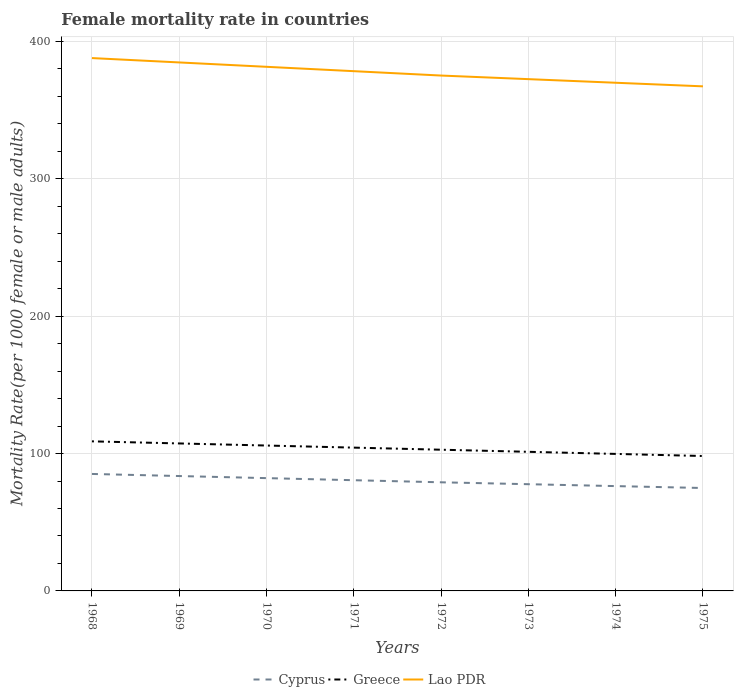How many different coloured lines are there?
Your response must be concise. 3. Is the number of lines equal to the number of legend labels?
Provide a succinct answer. Yes. Across all years, what is the maximum female mortality rate in Greece?
Give a very brief answer. 98.22. In which year was the female mortality rate in Cyprus maximum?
Offer a very short reply. 1975. What is the total female mortality rate in Lao PDR in the graph?
Your answer should be very brief. 9.54. What is the difference between the highest and the second highest female mortality rate in Cyprus?
Offer a terse response. 10.23. What is the difference between the highest and the lowest female mortality rate in Cyprus?
Your answer should be very brief. 4. How many lines are there?
Offer a very short reply. 3. How many years are there in the graph?
Give a very brief answer. 8. Does the graph contain grids?
Your answer should be compact. Yes. Where does the legend appear in the graph?
Keep it short and to the point. Bottom center. How many legend labels are there?
Make the answer very short. 3. How are the legend labels stacked?
Your answer should be very brief. Horizontal. What is the title of the graph?
Your answer should be compact. Female mortality rate in countries. What is the label or title of the X-axis?
Make the answer very short. Years. What is the label or title of the Y-axis?
Provide a short and direct response. Mortality Rate(per 1000 female or male adults). What is the Mortality Rate(per 1000 female or male adults) of Cyprus in 1968?
Your answer should be very brief. 85.16. What is the Mortality Rate(per 1000 female or male adults) in Greece in 1968?
Make the answer very short. 108.89. What is the Mortality Rate(per 1000 female or male adults) of Lao PDR in 1968?
Offer a terse response. 387.93. What is the Mortality Rate(per 1000 female or male adults) of Cyprus in 1969?
Offer a very short reply. 83.64. What is the Mortality Rate(per 1000 female or male adults) of Greece in 1969?
Your answer should be compact. 107.37. What is the Mortality Rate(per 1000 female or male adults) in Lao PDR in 1969?
Provide a succinct answer. 384.75. What is the Mortality Rate(per 1000 female or male adults) in Cyprus in 1970?
Offer a terse response. 82.12. What is the Mortality Rate(per 1000 female or male adults) of Greece in 1970?
Offer a terse response. 105.85. What is the Mortality Rate(per 1000 female or male adults) of Lao PDR in 1970?
Your answer should be very brief. 381.57. What is the Mortality Rate(per 1000 female or male adults) of Cyprus in 1971?
Provide a short and direct response. 80.6. What is the Mortality Rate(per 1000 female or male adults) in Greece in 1971?
Your answer should be compact. 104.33. What is the Mortality Rate(per 1000 female or male adults) of Lao PDR in 1971?
Your response must be concise. 378.39. What is the Mortality Rate(per 1000 female or male adults) in Cyprus in 1972?
Offer a terse response. 79.08. What is the Mortality Rate(per 1000 female or male adults) of Greece in 1972?
Your answer should be very brief. 102.8. What is the Mortality Rate(per 1000 female or male adults) of Lao PDR in 1972?
Provide a short and direct response. 375.2. What is the Mortality Rate(per 1000 female or male adults) in Cyprus in 1973?
Make the answer very short. 77.7. What is the Mortality Rate(per 1000 female or male adults) in Greece in 1973?
Keep it short and to the point. 101.28. What is the Mortality Rate(per 1000 female or male adults) of Lao PDR in 1973?
Give a very brief answer. 372.58. What is the Mortality Rate(per 1000 female or male adults) in Cyprus in 1974?
Give a very brief answer. 76.31. What is the Mortality Rate(per 1000 female or male adults) in Greece in 1974?
Keep it short and to the point. 99.75. What is the Mortality Rate(per 1000 female or male adults) in Lao PDR in 1974?
Ensure brevity in your answer.  369.96. What is the Mortality Rate(per 1000 female or male adults) of Cyprus in 1975?
Provide a succinct answer. 74.93. What is the Mortality Rate(per 1000 female or male adults) in Greece in 1975?
Your answer should be compact. 98.22. What is the Mortality Rate(per 1000 female or male adults) in Lao PDR in 1975?
Provide a short and direct response. 367.34. Across all years, what is the maximum Mortality Rate(per 1000 female or male adults) in Cyprus?
Offer a very short reply. 85.16. Across all years, what is the maximum Mortality Rate(per 1000 female or male adults) of Greece?
Keep it short and to the point. 108.89. Across all years, what is the maximum Mortality Rate(per 1000 female or male adults) in Lao PDR?
Offer a terse response. 387.93. Across all years, what is the minimum Mortality Rate(per 1000 female or male adults) in Cyprus?
Your answer should be very brief. 74.93. Across all years, what is the minimum Mortality Rate(per 1000 female or male adults) of Greece?
Your answer should be very brief. 98.22. Across all years, what is the minimum Mortality Rate(per 1000 female or male adults) of Lao PDR?
Your answer should be very brief. 367.34. What is the total Mortality Rate(per 1000 female or male adults) in Cyprus in the graph?
Your response must be concise. 639.53. What is the total Mortality Rate(per 1000 female or male adults) in Greece in the graph?
Your answer should be compact. 828.48. What is the total Mortality Rate(per 1000 female or male adults) of Lao PDR in the graph?
Your answer should be very brief. 3017.72. What is the difference between the Mortality Rate(per 1000 female or male adults) of Cyprus in 1968 and that in 1969?
Your answer should be compact. 1.52. What is the difference between the Mortality Rate(per 1000 female or male adults) of Greece in 1968 and that in 1969?
Give a very brief answer. 1.52. What is the difference between the Mortality Rate(per 1000 female or male adults) in Lao PDR in 1968 and that in 1969?
Offer a terse response. 3.18. What is the difference between the Mortality Rate(per 1000 female or male adults) of Cyprus in 1968 and that in 1970?
Keep it short and to the point. 3.04. What is the difference between the Mortality Rate(per 1000 female or male adults) of Greece in 1968 and that in 1970?
Provide a short and direct response. 3.04. What is the difference between the Mortality Rate(per 1000 female or male adults) of Lao PDR in 1968 and that in 1970?
Offer a very short reply. 6.36. What is the difference between the Mortality Rate(per 1000 female or male adults) of Cyprus in 1968 and that in 1971?
Make the answer very short. 4.56. What is the difference between the Mortality Rate(per 1000 female or male adults) of Greece in 1968 and that in 1971?
Give a very brief answer. 4.57. What is the difference between the Mortality Rate(per 1000 female or male adults) in Lao PDR in 1968 and that in 1971?
Provide a short and direct response. 9.54. What is the difference between the Mortality Rate(per 1000 female or male adults) of Cyprus in 1968 and that in 1972?
Give a very brief answer. 6.08. What is the difference between the Mortality Rate(per 1000 female or male adults) of Greece in 1968 and that in 1972?
Your answer should be very brief. 6.09. What is the difference between the Mortality Rate(per 1000 female or male adults) of Lao PDR in 1968 and that in 1972?
Your response must be concise. 12.72. What is the difference between the Mortality Rate(per 1000 female or male adults) of Cyprus in 1968 and that in 1973?
Give a very brief answer. 7.46. What is the difference between the Mortality Rate(per 1000 female or male adults) in Greece in 1968 and that in 1973?
Make the answer very short. 7.62. What is the difference between the Mortality Rate(per 1000 female or male adults) of Lao PDR in 1968 and that in 1973?
Make the answer very short. 15.34. What is the difference between the Mortality Rate(per 1000 female or male adults) of Cyprus in 1968 and that in 1974?
Offer a very short reply. 8.85. What is the difference between the Mortality Rate(per 1000 female or male adults) of Greece in 1968 and that in 1974?
Make the answer very short. 9.14. What is the difference between the Mortality Rate(per 1000 female or male adults) in Lao PDR in 1968 and that in 1974?
Your response must be concise. 17.96. What is the difference between the Mortality Rate(per 1000 female or male adults) in Cyprus in 1968 and that in 1975?
Your response must be concise. 10.23. What is the difference between the Mortality Rate(per 1000 female or male adults) of Greece in 1968 and that in 1975?
Ensure brevity in your answer.  10.67. What is the difference between the Mortality Rate(per 1000 female or male adults) in Lao PDR in 1968 and that in 1975?
Provide a short and direct response. 20.58. What is the difference between the Mortality Rate(per 1000 female or male adults) in Cyprus in 1969 and that in 1970?
Give a very brief answer. 1.52. What is the difference between the Mortality Rate(per 1000 female or male adults) of Greece in 1969 and that in 1970?
Your answer should be compact. 1.52. What is the difference between the Mortality Rate(per 1000 female or male adults) in Lao PDR in 1969 and that in 1970?
Provide a short and direct response. 3.18. What is the difference between the Mortality Rate(per 1000 female or male adults) in Cyprus in 1969 and that in 1971?
Offer a terse response. 3.04. What is the difference between the Mortality Rate(per 1000 female or male adults) of Greece in 1969 and that in 1971?
Ensure brevity in your answer.  3.04. What is the difference between the Mortality Rate(per 1000 female or male adults) in Lao PDR in 1969 and that in 1971?
Give a very brief answer. 6.36. What is the difference between the Mortality Rate(per 1000 female or male adults) of Cyprus in 1969 and that in 1972?
Offer a very short reply. 4.56. What is the difference between the Mortality Rate(per 1000 female or male adults) of Greece in 1969 and that in 1972?
Offer a terse response. 4.57. What is the difference between the Mortality Rate(per 1000 female or male adults) of Lao PDR in 1969 and that in 1972?
Your answer should be very brief. 9.54. What is the difference between the Mortality Rate(per 1000 female or male adults) in Cyprus in 1969 and that in 1973?
Your answer should be compact. 5.94. What is the difference between the Mortality Rate(per 1000 female or male adults) in Greece in 1969 and that in 1973?
Provide a succinct answer. 6.09. What is the difference between the Mortality Rate(per 1000 female or male adults) of Lao PDR in 1969 and that in 1973?
Keep it short and to the point. 12.16. What is the difference between the Mortality Rate(per 1000 female or male adults) in Cyprus in 1969 and that in 1974?
Your response must be concise. 7.33. What is the difference between the Mortality Rate(per 1000 female or male adults) in Greece in 1969 and that in 1974?
Offer a very short reply. 7.62. What is the difference between the Mortality Rate(per 1000 female or male adults) of Lao PDR in 1969 and that in 1974?
Provide a short and direct response. 14.78. What is the difference between the Mortality Rate(per 1000 female or male adults) of Cyprus in 1969 and that in 1975?
Provide a short and direct response. 8.71. What is the difference between the Mortality Rate(per 1000 female or male adults) in Greece in 1969 and that in 1975?
Offer a very short reply. 9.15. What is the difference between the Mortality Rate(per 1000 female or male adults) of Lao PDR in 1969 and that in 1975?
Offer a very short reply. 17.4. What is the difference between the Mortality Rate(per 1000 female or male adults) in Cyprus in 1970 and that in 1971?
Your answer should be very brief. 1.52. What is the difference between the Mortality Rate(per 1000 female or male adults) of Greece in 1970 and that in 1971?
Make the answer very short. 1.52. What is the difference between the Mortality Rate(per 1000 female or male adults) in Lao PDR in 1970 and that in 1971?
Keep it short and to the point. 3.18. What is the difference between the Mortality Rate(per 1000 female or male adults) of Cyprus in 1970 and that in 1972?
Your answer should be very brief. 3.04. What is the difference between the Mortality Rate(per 1000 female or male adults) of Greece in 1970 and that in 1972?
Give a very brief answer. 3.04. What is the difference between the Mortality Rate(per 1000 female or male adults) of Lao PDR in 1970 and that in 1972?
Give a very brief answer. 6.36. What is the difference between the Mortality Rate(per 1000 female or male adults) in Cyprus in 1970 and that in 1973?
Provide a succinct answer. 4.42. What is the difference between the Mortality Rate(per 1000 female or male adults) of Greece in 1970 and that in 1973?
Offer a very short reply. 4.57. What is the difference between the Mortality Rate(per 1000 female or male adults) in Lao PDR in 1970 and that in 1973?
Ensure brevity in your answer.  8.98. What is the difference between the Mortality Rate(per 1000 female or male adults) in Cyprus in 1970 and that in 1974?
Provide a succinct answer. 5.81. What is the difference between the Mortality Rate(per 1000 female or male adults) in Greece in 1970 and that in 1974?
Keep it short and to the point. 6.1. What is the difference between the Mortality Rate(per 1000 female or male adults) in Lao PDR in 1970 and that in 1974?
Give a very brief answer. 11.6. What is the difference between the Mortality Rate(per 1000 female or male adults) in Cyprus in 1970 and that in 1975?
Provide a short and direct response. 7.19. What is the difference between the Mortality Rate(per 1000 female or male adults) in Greece in 1970 and that in 1975?
Give a very brief answer. 7.63. What is the difference between the Mortality Rate(per 1000 female or male adults) of Lao PDR in 1970 and that in 1975?
Ensure brevity in your answer.  14.22. What is the difference between the Mortality Rate(per 1000 female or male adults) of Cyprus in 1971 and that in 1972?
Ensure brevity in your answer.  1.52. What is the difference between the Mortality Rate(per 1000 female or male adults) of Greece in 1971 and that in 1972?
Offer a terse response. 1.52. What is the difference between the Mortality Rate(per 1000 female or male adults) of Lao PDR in 1971 and that in 1972?
Give a very brief answer. 3.18. What is the difference between the Mortality Rate(per 1000 female or male adults) in Cyprus in 1971 and that in 1973?
Your response must be concise. 2.9. What is the difference between the Mortality Rate(per 1000 female or male adults) in Greece in 1971 and that in 1973?
Your answer should be very brief. 3.05. What is the difference between the Mortality Rate(per 1000 female or male adults) of Lao PDR in 1971 and that in 1973?
Keep it short and to the point. 5.8. What is the difference between the Mortality Rate(per 1000 female or male adults) of Cyprus in 1971 and that in 1974?
Your answer should be very brief. 4.29. What is the difference between the Mortality Rate(per 1000 female or male adults) of Greece in 1971 and that in 1974?
Ensure brevity in your answer.  4.58. What is the difference between the Mortality Rate(per 1000 female or male adults) in Lao PDR in 1971 and that in 1974?
Provide a succinct answer. 8.42. What is the difference between the Mortality Rate(per 1000 female or male adults) in Cyprus in 1971 and that in 1975?
Your response must be concise. 5.67. What is the difference between the Mortality Rate(per 1000 female or male adults) in Greece in 1971 and that in 1975?
Provide a short and direct response. 6.1. What is the difference between the Mortality Rate(per 1000 female or male adults) in Lao PDR in 1971 and that in 1975?
Make the answer very short. 11.04. What is the difference between the Mortality Rate(per 1000 female or male adults) in Cyprus in 1972 and that in 1973?
Your answer should be compact. 1.39. What is the difference between the Mortality Rate(per 1000 female or male adults) in Greece in 1972 and that in 1973?
Your answer should be very brief. 1.53. What is the difference between the Mortality Rate(per 1000 female or male adults) of Lao PDR in 1972 and that in 1973?
Provide a short and direct response. 2.62. What is the difference between the Mortality Rate(per 1000 female or male adults) in Cyprus in 1972 and that in 1974?
Provide a succinct answer. 2.77. What is the difference between the Mortality Rate(per 1000 female or male adults) of Greece in 1972 and that in 1974?
Offer a terse response. 3.05. What is the difference between the Mortality Rate(per 1000 female or male adults) of Lao PDR in 1972 and that in 1974?
Provide a short and direct response. 5.24. What is the difference between the Mortality Rate(per 1000 female or male adults) of Cyprus in 1972 and that in 1975?
Your answer should be compact. 4.16. What is the difference between the Mortality Rate(per 1000 female or male adults) in Greece in 1972 and that in 1975?
Offer a very short reply. 4.58. What is the difference between the Mortality Rate(per 1000 female or male adults) of Lao PDR in 1972 and that in 1975?
Your answer should be compact. 7.86. What is the difference between the Mortality Rate(per 1000 female or male adults) of Cyprus in 1973 and that in 1974?
Your answer should be very brief. 1.39. What is the difference between the Mortality Rate(per 1000 female or male adults) of Greece in 1973 and that in 1974?
Offer a terse response. 1.53. What is the difference between the Mortality Rate(per 1000 female or male adults) in Lao PDR in 1973 and that in 1974?
Provide a short and direct response. 2.62. What is the difference between the Mortality Rate(per 1000 female or male adults) of Cyprus in 1973 and that in 1975?
Provide a short and direct response. 2.77. What is the difference between the Mortality Rate(per 1000 female or male adults) in Greece in 1973 and that in 1975?
Make the answer very short. 3.05. What is the difference between the Mortality Rate(per 1000 female or male adults) in Lao PDR in 1973 and that in 1975?
Make the answer very short. 5.24. What is the difference between the Mortality Rate(per 1000 female or male adults) of Cyprus in 1974 and that in 1975?
Offer a very short reply. 1.39. What is the difference between the Mortality Rate(per 1000 female or male adults) of Greece in 1974 and that in 1975?
Give a very brief answer. 1.53. What is the difference between the Mortality Rate(per 1000 female or male adults) in Lao PDR in 1974 and that in 1975?
Provide a succinct answer. 2.62. What is the difference between the Mortality Rate(per 1000 female or male adults) in Cyprus in 1968 and the Mortality Rate(per 1000 female or male adults) in Greece in 1969?
Your answer should be compact. -22.21. What is the difference between the Mortality Rate(per 1000 female or male adults) of Cyprus in 1968 and the Mortality Rate(per 1000 female or male adults) of Lao PDR in 1969?
Your response must be concise. -299.59. What is the difference between the Mortality Rate(per 1000 female or male adults) of Greece in 1968 and the Mortality Rate(per 1000 female or male adults) of Lao PDR in 1969?
Your answer should be compact. -275.85. What is the difference between the Mortality Rate(per 1000 female or male adults) of Cyprus in 1968 and the Mortality Rate(per 1000 female or male adults) of Greece in 1970?
Offer a very short reply. -20.69. What is the difference between the Mortality Rate(per 1000 female or male adults) in Cyprus in 1968 and the Mortality Rate(per 1000 female or male adults) in Lao PDR in 1970?
Keep it short and to the point. -296.41. What is the difference between the Mortality Rate(per 1000 female or male adults) in Greece in 1968 and the Mortality Rate(per 1000 female or male adults) in Lao PDR in 1970?
Your response must be concise. -272.67. What is the difference between the Mortality Rate(per 1000 female or male adults) of Cyprus in 1968 and the Mortality Rate(per 1000 female or male adults) of Greece in 1971?
Ensure brevity in your answer.  -19.17. What is the difference between the Mortality Rate(per 1000 female or male adults) of Cyprus in 1968 and the Mortality Rate(per 1000 female or male adults) of Lao PDR in 1971?
Ensure brevity in your answer.  -293.23. What is the difference between the Mortality Rate(per 1000 female or male adults) of Greece in 1968 and the Mortality Rate(per 1000 female or male adults) of Lao PDR in 1971?
Offer a terse response. -269.49. What is the difference between the Mortality Rate(per 1000 female or male adults) in Cyprus in 1968 and the Mortality Rate(per 1000 female or male adults) in Greece in 1972?
Provide a succinct answer. -17.65. What is the difference between the Mortality Rate(per 1000 female or male adults) of Cyprus in 1968 and the Mortality Rate(per 1000 female or male adults) of Lao PDR in 1972?
Give a very brief answer. -290.05. What is the difference between the Mortality Rate(per 1000 female or male adults) in Greece in 1968 and the Mortality Rate(per 1000 female or male adults) in Lao PDR in 1972?
Give a very brief answer. -266.31. What is the difference between the Mortality Rate(per 1000 female or male adults) of Cyprus in 1968 and the Mortality Rate(per 1000 female or male adults) of Greece in 1973?
Offer a terse response. -16.12. What is the difference between the Mortality Rate(per 1000 female or male adults) of Cyprus in 1968 and the Mortality Rate(per 1000 female or male adults) of Lao PDR in 1973?
Your answer should be compact. -287.43. What is the difference between the Mortality Rate(per 1000 female or male adults) in Greece in 1968 and the Mortality Rate(per 1000 female or male adults) in Lao PDR in 1973?
Your answer should be compact. -263.69. What is the difference between the Mortality Rate(per 1000 female or male adults) in Cyprus in 1968 and the Mortality Rate(per 1000 female or male adults) in Greece in 1974?
Provide a short and direct response. -14.59. What is the difference between the Mortality Rate(per 1000 female or male adults) of Cyprus in 1968 and the Mortality Rate(per 1000 female or male adults) of Lao PDR in 1974?
Make the answer very short. -284.81. What is the difference between the Mortality Rate(per 1000 female or male adults) in Greece in 1968 and the Mortality Rate(per 1000 female or male adults) in Lao PDR in 1974?
Your answer should be very brief. -261.07. What is the difference between the Mortality Rate(per 1000 female or male adults) of Cyprus in 1968 and the Mortality Rate(per 1000 female or male adults) of Greece in 1975?
Provide a succinct answer. -13.06. What is the difference between the Mortality Rate(per 1000 female or male adults) of Cyprus in 1968 and the Mortality Rate(per 1000 female or male adults) of Lao PDR in 1975?
Provide a short and direct response. -282.19. What is the difference between the Mortality Rate(per 1000 female or male adults) of Greece in 1968 and the Mortality Rate(per 1000 female or male adults) of Lao PDR in 1975?
Offer a very short reply. -258.45. What is the difference between the Mortality Rate(per 1000 female or male adults) of Cyprus in 1969 and the Mortality Rate(per 1000 female or male adults) of Greece in 1970?
Your answer should be very brief. -22.21. What is the difference between the Mortality Rate(per 1000 female or male adults) in Cyprus in 1969 and the Mortality Rate(per 1000 female or male adults) in Lao PDR in 1970?
Offer a terse response. -297.93. What is the difference between the Mortality Rate(per 1000 female or male adults) of Greece in 1969 and the Mortality Rate(per 1000 female or male adults) of Lao PDR in 1970?
Your response must be concise. -274.2. What is the difference between the Mortality Rate(per 1000 female or male adults) in Cyprus in 1969 and the Mortality Rate(per 1000 female or male adults) in Greece in 1971?
Make the answer very short. -20.69. What is the difference between the Mortality Rate(per 1000 female or male adults) of Cyprus in 1969 and the Mortality Rate(per 1000 female or male adults) of Lao PDR in 1971?
Your answer should be very brief. -294.75. What is the difference between the Mortality Rate(per 1000 female or male adults) in Greece in 1969 and the Mortality Rate(per 1000 female or male adults) in Lao PDR in 1971?
Offer a terse response. -271.02. What is the difference between the Mortality Rate(per 1000 female or male adults) in Cyprus in 1969 and the Mortality Rate(per 1000 female or male adults) in Greece in 1972?
Your answer should be very brief. -19.16. What is the difference between the Mortality Rate(per 1000 female or male adults) of Cyprus in 1969 and the Mortality Rate(per 1000 female or male adults) of Lao PDR in 1972?
Your response must be concise. -291.57. What is the difference between the Mortality Rate(per 1000 female or male adults) of Greece in 1969 and the Mortality Rate(per 1000 female or male adults) of Lao PDR in 1972?
Your response must be concise. -267.83. What is the difference between the Mortality Rate(per 1000 female or male adults) in Cyprus in 1969 and the Mortality Rate(per 1000 female or male adults) in Greece in 1973?
Your answer should be compact. -17.64. What is the difference between the Mortality Rate(per 1000 female or male adults) in Cyprus in 1969 and the Mortality Rate(per 1000 female or male adults) in Lao PDR in 1973?
Keep it short and to the point. -288.95. What is the difference between the Mortality Rate(per 1000 female or male adults) in Greece in 1969 and the Mortality Rate(per 1000 female or male adults) in Lao PDR in 1973?
Ensure brevity in your answer.  -265.21. What is the difference between the Mortality Rate(per 1000 female or male adults) in Cyprus in 1969 and the Mortality Rate(per 1000 female or male adults) in Greece in 1974?
Provide a succinct answer. -16.11. What is the difference between the Mortality Rate(per 1000 female or male adults) of Cyprus in 1969 and the Mortality Rate(per 1000 female or male adults) of Lao PDR in 1974?
Your answer should be compact. -286.32. What is the difference between the Mortality Rate(per 1000 female or male adults) of Greece in 1969 and the Mortality Rate(per 1000 female or male adults) of Lao PDR in 1974?
Ensure brevity in your answer.  -262.59. What is the difference between the Mortality Rate(per 1000 female or male adults) of Cyprus in 1969 and the Mortality Rate(per 1000 female or male adults) of Greece in 1975?
Your answer should be compact. -14.58. What is the difference between the Mortality Rate(per 1000 female or male adults) of Cyprus in 1969 and the Mortality Rate(per 1000 female or male adults) of Lao PDR in 1975?
Provide a short and direct response. -283.7. What is the difference between the Mortality Rate(per 1000 female or male adults) of Greece in 1969 and the Mortality Rate(per 1000 female or male adults) of Lao PDR in 1975?
Ensure brevity in your answer.  -259.97. What is the difference between the Mortality Rate(per 1000 female or male adults) of Cyprus in 1970 and the Mortality Rate(per 1000 female or male adults) of Greece in 1971?
Give a very brief answer. -22.21. What is the difference between the Mortality Rate(per 1000 female or male adults) in Cyprus in 1970 and the Mortality Rate(per 1000 female or male adults) in Lao PDR in 1971?
Make the answer very short. -296.27. What is the difference between the Mortality Rate(per 1000 female or male adults) in Greece in 1970 and the Mortality Rate(per 1000 female or male adults) in Lao PDR in 1971?
Ensure brevity in your answer.  -272.54. What is the difference between the Mortality Rate(per 1000 female or male adults) of Cyprus in 1970 and the Mortality Rate(per 1000 female or male adults) of Greece in 1972?
Keep it short and to the point. -20.68. What is the difference between the Mortality Rate(per 1000 female or male adults) in Cyprus in 1970 and the Mortality Rate(per 1000 female or male adults) in Lao PDR in 1972?
Give a very brief answer. -293.08. What is the difference between the Mortality Rate(per 1000 female or male adults) in Greece in 1970 and the Mortality Rate(per 1000 female or male adults) in Lao PDR in 1972?
Your answer should be compact. -269.36. What is the difference between the Mortality Rate(per 1000 female or male adults) in Cyprus in 1970 and the Mortality Rate(per 1000 female or male adults) in Greece in 1973?
Your response must be concise. -19.16. What is the difference between the Mortality Rate(per 1000 female or male adults) in Cyprus in 1970 and the Mortality Rate(per 1000 female or male adults) in Lao PDR in 1973?
Ensure brevity in your answer.  -290.46. What is the difference between the Mortality Rate(per 1000 female or male adults) in Greece in 1970 and the Mortality Rate(per 1000 female or male adults) in Lao PDR in 1973?
Offer a very short reply. -266.74. What is the difference between the Mortality Rate(per 1000 female or male adults) in Cyprus in 1970 and the Mortality Rate(per 1000 female or male adults) in Greece in 1974?
Your answer should be compact. -17.63. What is the difference between the Mortality Rate(per 1000 female or male adults) of Cyprus in 1970 and the Mortality Rate(per 1000 female or male adults) of Lao PDR in 1974?
Offer a terse response. -287.84. What is the difference between the Mortality Rate(per 1000 female or male adults) in Greece in 1970 and the Mortality Rate(per 1000 female or male adults) in Lao PDR in 1974?
Ensure brevity in your answer.  -264.12. What is the difference between the Mortality Rate(per 1000 female or male adults) in Cyprus in 1970 and the Mortality Rate(per 1000 female or male adults) in Greece in 1975?
Offer a terse response. -16.1. What is the difference between the Mortality Rate(per 1000 female or male adults) in Cyprus in 1970 and the Mortality Rate(per 1000 female or male adults) in Lao PDR in 1975?
Offer a very short reply. -285.22. What is the difference between the Mortality Rate(per 1000 female or male adults) in Greece in 1970 and the Mortality Rate(per 1000 female or male adults) in Lao PDR in 1975?
Give a very brief answer. -261.49. What is the difference between the Mortality Rate(per 1000 female or male adults) of Cyprus in 1971 and the Mortality Rate(per 1000 female or male adults) of Greece in 1972?
Provide a short and direct response. -22.2. What is the difference between the Mortality Rate(per 1000 female or male adults) of Cyprus in 1971 and the Mortality Rate(per 1000 female or male adults) of Lao PDR in 1972?
Give a very brief answer. -294.6. What is the difference between the Mortality Rate(per 1000 female or male adults) of Greece in 1971 and the Mortality Rate(per 1000 female or male adults) of Lao PDR in 1972?
Offer a terse response. -270.88. What is the difference between the Mortality Rate(per 1000 female or male adults) of Cyprus in 1971 and the Mortality Rate(per 1000 female or male adults) of Greece in 1973?
Make the answer very short. -20.67. What is the difference between the Mortality Rate(per 1000 female or male adults) in Cyprus in 1971 and the Mortality Rate(per 1000 female or male adults) in Lao PDR in 1973?
Offer a very short reply. -291.98. What is the difference between the Mortality Rate(per 1000 female or male adults) of Greece in 1971 and the Mortality Rate(per 1000 female or male adults) of Lao PDR in 1973?
Make the answer very short. -268.26. What is the difference between the Mortality Rate(per 1000 female or male adults) of Cyprus in 1971 and the Mortality Rate(per 1000 female or male adults) of Greece in 1974?
Provide a succinct answer. -19.15. What is the difference between the Mortality Rate(per 1000 female or male adults) of Cyprus in 1971 and the Mortality Rate(per 1000 female or male adults) of Lao PDR in 1974?
Keep it short and to the point. -289.36. What is the difference between the Mortality Rate(per 1000 female or male adults) of Greece in 1971 and the Mortality Rate(per 1000 female or male adults) of Lao PDR in 1974?
Your response must be concise. -265.64. What is the difference between the Mortality Rate(per 1000 female or male adults) in Cyprus in 1971 and the Mortality Rate(per 1000 female or male adults) in Greece in 1975?
Keep it short and to the point. -17.62. What is the difference between the Mortality Rate(per 1000 female or male adults) of Cyprus in 1971 and the Mortality Rate(per 1000 female or male adults) of Lao PDR in 1975?
Give a very brief answer. -286.74. What is the difference between the Mortality Rate(per 1000 female or male adults) of Greece in 1971 and the Mortality Rate(per 1000 female or male adults) of Lao PDR in 1975?
Offer a terse response. -263.02. What is the difference between the Mortality Rate(per 1000 female or male adults) in Cyprus in 1972 and the Mortality Rate(per 1000 female or male adults) in Greece in 1973?
Offer a terse response. -22.19. What is the difference between the Mortality Rate(per 1000 female or male adults) in Cyprus in 1972 and the Mortality Rate(per 1000 female or male adults) in Lao PDR in 1973?
Ensure brevity in your answer.  -293.5. What is the difference between the Mortality Rate(per 1000 female or male adults) in Greece in 1972 and the Mortality Rate(per 1000 female or male adults) in Lao PDR in 1973?
Your response must be concise. -269.78. What is the difference between the Mortality Rate(per 1000 female or male adults) of Cyprus in 1972 and the Mortality Rate(per 1000 female or male adults) of Greece in 1974?
Make the answer very short. -20.67. What is the difference between the Mortality Rate(per 1000 female or male adults) in Cyprus in 1972 and the Mortality Rate(per 1000 female or male adults) in Lao PDR in 1974?
Offer a terse response. -290.88. What is the difference between the Mortality Rate(per 1000 female or male adults) of Greece in 1972 and the Mortality Rate(per 1000 female or male adults) of Lao PDR in 1974?
Make the answer very short. -267.16. What is the difference between the Mortality Rate(per 1000 female or male adults) in Cyprus in 1972 and the Mortality Rate(per 1000 female or male adults) in Greece in 1975?
Ensure brevity in your answer.  -19.14. What is the difference between the Mortality Rate(per 1000 female or male adults) in Cyprus in 1972 and the Mortality Rate(per 1000 female or male adults) in Lao PDR in 1975?
Offer a very short reply. -288.26. What is the difference between the Mortality Rate(per 1000 female or male adults) in Greece in 1972 and the Mortality Rate(per 1000 female or male adults) in Lao PDR in 1975?
Your answer should be compact. -264.54. What is the difference between the Mortality Rate(per 1000 female or male adults) of Cyprus in 1973 and the Mortality Rate(per 1000 female or male adults) of Greece in 1974?
Provide a succinct answer. -22.05. What is the difference between the Mortality Rate(per 1000 female or male adults) of Cyprus in 1973 and the Mortality Rate(per 1000 female or male adults) of Lao PDR in 1974?
Keep it short and to the point. -292.27. What is the difference between the Mortality Rate(per 1000 female or male adults) in Greece in 1973 and the Mortality Rate(per 1000 female or male adults) in Lao PDR in 1974?
Your response must be concise. -268.69. What is the difference between the Mortality Rate(per 1000 female or male adults) of Cyprus in 1973 and the Mortality Rate(per 1000 female or male adults) of Greece in 1975?
Offer a terse response. -20.52. What is the difference between the Mortality Rate(per 1000 female or male adults) of Cyprus in 1973 and the Mortality Rate(per 1000 female or male adults) of Lao PDR in 1975?
Give a very brief answer. -289.64. What is the difference between the Mortality Rate(per 1000 female or male adults) of Greece in 1973 and the Mortality Rate(per 1000 female or male adults) of Lao PDR in 1975?
Make the answer very short. -266.07. What is the difference between the Mortality Rate(per 1000 female or male adults) of Cyprus in 1974 and the Mortality Rate(per 1000 female or male adults) of Greece in 1975?
Offer a very short reply. -21.91. What is the difference between the Mortality Rate(per 1000 female or male adults) of Cyprus in 1974 and the Mortality Rate(per 1000 female or male adults) of Lao PDR in 1975?
Your response must be concise. -291.03. What is the difference between the Mortality Rate(per 1000 female or male adults) of Greece in 1974 and the Mortality Rate(per 1000 female or male adults) of Lao PDR in 1975?
Make the answer very short. -267.59. What is the average Mortality Rate(per 1000 female or male adults) of Cyprus per year?
Offer a very short reply. 79.94. What is the average Mortality Rate(per 1000 female or male adults) of Greece per year?
Offer a very short reply. 103.56. What is the average Mortality Rate(per 1000 female or male adults) in Lao PDR per year?
Give a very brief answer. 377.21. In the year 1968, what is the difference between the Mortality Rate(per 1000 female or male adults) of Cyprus and Mortality Rate(per 1000 female or male adults) of Greece?
Ensure brevity in your answer.  -23.74. In the year 1968, what is the difference between the Mortality Rate(per 1000 female or male adults) of Cyprus and Mortality Rate(per 1000 female or male adults) of Lao PDR?
Your response must be concise. -302.77. In the year 1968, what is the difference between the Mortality Rate(per 1000 female or male adults) in Greece and Mortality Rate(per 1000 female or male adults) in Lao PDR?
Offer a terse response. -279.03. In the year 1969, what is the difference between the Mortality Rate(per 1000 female or male adults) in Cyprus and Mortality Rate(per 1000 female or male adults) in Greece?
Your answer should be compact. -23.73. In the year 1969, what is the difference between the Mortality Rate(per 1000 female or male adults) of Cyprus and Mortality Rate(per 1000 female or male adults) of Lao PDR?
Provide a short and direct response. -301.11. In the year 1969, what is the difference between the Mortality Rate(per 1000 female or male adults) in Greece and Mortality Rate(per 1000 female or male adults) in Lao PDR?
Provide a short and direct response. -277.38. In the year 1970, what is the difference between the Mortality Rate(per 1000 female or male adults) of Cyprus and Mortality Rate(per 1000 female or male adults) of Greece?
Your answer should be very brief. -23.73. In the year 1970, what is the difference between the Mortality Rate(per 1000 female or male adults) in Cyprus and Mortality Rate(per 1000 female or male adults) in Lao PDR?
Ensure brevity in your answer.  -299.45. In the year 1970, what is the difference between the Mortality Rate(per 1000 female or male adults) of Greece and Mortality Rate(per 1000 female or male adults) of Lao PDR?
Make the answer very short. -275.72. In the year 1971, what is the difference between the Mortality Rate(per 1000 female or male adults) in Cyprus and Mortality Rate(per 1000 female or male adults) in Greece?
Make the answer very short. -23.72. In the year 1971, what is the difference between the Mortality Rate(per 1000 female or male adults) of Cyprus and Mortality Rate(per 1000 female or male adults) of Lao PDR?
Provide a succinct answer. -297.79. In the year 1971, what is the difference between the Mortality Rate(per 1000 female or male adults) in Greece and Mortality Rate(per 1000 female or male adults) in Lao PDR?
Your response must be concise. -274.06. In the year 1972, what is the difference between the Mortality Rate(per 1000 female or male adults) of Cyprus and Mortality Rate(per 1000 female or male adults) of Greece?
Offer a terse response. -23.72. In the year 1972, what is the difference between the Mortality Rate(per 1000 female or male adults) in Cyprus and Mortality Rate(per 1000 female or male adults) in Lao PDR?
Provide a succinct answer. -296.12. In the year 1972, what is the difference between the Mortality Rate(per 1000 female or male adults) of Greece and Mortality Rate(per 1000 female or male adults) of Lao PDR?
Your answer should be very brief. -272.4. In the year 1973, what is the difference between the Mortality Rate(per 1000 female or male adults) in Cyprus and Mortality Rate(per 1000 female or male adults) in Greece?
Your response must be concise. -23.58. In the year 1973, what is the difference between the Mortality Rate(per 1000 female or male adults) in Cyprus and Mortality Rate(per 1000 female or male adults) in Lao PDR?
Your response must be concise. -294.89. In the year 1973, what is the difference between the Mortality Rate(per 1000 female or male adults) in Greece and Mortality Rate(per 1000 female or male adults) in Lao PDR?
Your response must be concise. -271.31. In the year 1974, what is the difference between the Mortality Rate(per 1000 female or male adults) of Cyprus and Mortality Rate(per 1000 female or male adults) of Greece?
Your response must be concise. -23.44. In the year 1974, what is the difference between the Mortality Rate(per 1000 female or male adults) in Cyprus and Mortality Rate(per 1000 female or male adults) in Lao PDR?
Offer a very short reply. -293.65. In the year 1974, what is the difference between the Mortality Rate(per 1000 female or male adults) of Greece and Mortality Rate(per 1000 female or male adults) of Lao PDR?
Your response must be concise. -270.21. In the year 1975, what is the difference between the Mortality Rate(per 1000 female or male adults) of Cyprus and Mortality Rate(per 1000 female or male adults) of Greece?
Your answer should be very brief. -23.3. In the year 1975, what is the difference between the Mortality Rate(per 1000 female or male adults) of Cyprus and Mortality Rate(per 1000 female or male adults) of Lao PDR?
Your answer should be very brief. -292.42. In the year 1975, what is the difference between the Mortality Rate(per 1000 female or male adults) of Greece and Mortality Rate(per 1000 female or male adults) of Lao PDR?
Your answer should be very brief. -269.12. What is the ratio of the Mortality Rate(per 1000 female or male adults) of Cyprus in 1968 to that in 1969?
Your answer should be compact. 1.02. What is the ratio of the Mortality Rate(per 1000 female or male adults) of Greece in 1968 to that in 1969?
Offer a very short reply. 1.01. What is the ratio of the Mortality Rate(per 1000 female or male adults) in Lao PDR in 1968 to that in 1969?
Provide a short and direct response. 1.01. What is the ratio of the Mortality Rate(per 1000 female or male adults) of Cyprus in 1968 to that in 1970?
Give a very brief answer. 1.04. What is the ratio of the Mortality Rate(per 1000 female or male adults) in Greece in 1968 to that in 1970?
Your answer should be very brief. 1.03. What is the ratio of the Mortality Rate(per 1000 female or male adults) of Lao PDR in 1968 to that in 1970?
Ensure brevity in your answer.  1.02. What is the ratio of the Mortality Rate(per 1000 female or male adults) of Cyprus in 1968 to that in 1971?
Your answer should be very brief. 1.06. What is the ratio of the Mortality Rate(per 1000 female or male adults) in Greece in 1968 to that in 1971?
Offer a very short reply. 1.04. What is the ratio of the Mortality Rate(per 1000 female or male adults) in Lao PDR in 1968 to that in 1971?
Provide a succinct answer. 1.03. What is the ratio of the Mortality Rate(per 1000 female or male adults) of Cyprus in 1968 to that in 1972?
Keep it short and to the point. 1.08. What is the ratio of the Mortality Rate(per 1000 female or male adults) in Greece in 1968 to that in 1972?
Ensure brevity in your answer.  1.06. What is the ratio of the Mortality Rate(per 1000 female or male adults) in Lao PDR in 1968 to that in 1972?
Your answer should be compact. 1.03. What is the ratio of the Mortality Rate(per 1000 female or male adults) in Cyprus in 1968 to that in 1973?
Provide a short and direct response. 1.1. What is the ratio of the Mortality Rate(per 1000 female or male adults) of Greece in 1968 to that in 1973?
Keep it short and to the point. 1.08. What is the ratio of the Mortality Rate(per 1000 female or male adults) in Lao PDR in 1968 to that in 1973?
Provide a short and direct response. 1.04. What is the ratio of the Mortality Rate(per 1000 female or male adults) of Cyprus in 1968 to that in 1974?
Ensure brevity in your answer.  1.12. What is the ratio of the Mortality Rate(per 1000 female or male adults) in Greece in 1968 to that in 1974?
Your response must be concise. 1.09. What is the ratio of the Mortality Rate(per 1000 female or male adults) in Lao PDR in 1968 to that in 1974?
Your response must be concise. 1.05. What is the ratio of the Mortality Rate(per 1000 female or male adults) in Cyprus in 1968 to that in 1975?
Provide a short and direct response. 1.14. What is the ratio of the Mortality Rate(per 1000 female or male adults) of Greece in 1968 to that in 1975?
Your answer should be compact. 1.11. What is the ratio of the Mortality Rate(per 1000 female or male adults) of Lao PDR in 1968 to that in 1975?
Offer a very short reply. 1.06. What is the ratio of the Mortality Rate(per 1000 female or male adults) of Cyprus in 1969 to that in 1970?
Your answer should be compact. 1.02. What is the ratio of the Mortality Rate(per 1000 female or male adults) in Greece in 1969 to that in 1970?
Provide a short and direct response. 1.01. What is the ratio of the Mortality Rate(per 1000 female or male adults) of Lao PDR in 1969 to that in 1970?
Offer a very short reply. 1.01. What is the ratio of the Mortality Rate(per 1000 female or male adults) of Cyprus in 1969 to that in 1971?
Your answer should be compact. 1.04. What is the ratio of the Mortality Rate(per 1000 female or male adults) in Greece in 1969 to that in 1971?
Make the answer very short. 1.03. What is the ratio of the Mortality Rate(per 1000 female or male adults) in Lao PDR in 1969 to that in 1971?
Keep it short and to the point. 1.02. What is the ratio of the Mortality Rate(per 1000 female or male adults) in Cyprus in 1969 to that in 1972?
Keep it short and to the point. 1.06. What is the ratio of the Mortality Rate(per 1000 female or male adults) in Greece in 1969 to that in 1972?
Your response must be concise. 1.04. What is the ratio of the Mortality Rate(per 1000 female or male adults) of Lao PDR in 1969 to that in 1972?
Your response must be concise. 1.03. What is the ratio of the Mortality Rate(per 1000 female or male adults) of Cyprus in 1969 to that in 1973?
Provide a succinct answer. 1.08. What is the ratio of the Mortality Rate(per 1000 female or male adults) of Greece in 1969 to that in 1973?
Your answer should be compact. 1.06. What is the ratio of the Mortality Rate(per 1000 female or male adults) in Lao PDR in 1969 to that in 1973?
Offer a very short reply. 1.03. What is the ratio of the Mortality Rate(per 1000 female or male adults) in Cyprus in 1969 to that in 1974?
Give a very brief answer. 1.1. What is the ratio of the Mortality Rate(per 1000 female or male adults) of Greece in 1969 to that in 1974?
Provide a succinct answer. 1.08. What is the ratio of the Mortality Rate(per 1000 female or male adults) of Cyprus in 1969 to that in 1975?
Provide a short and direct response. 1.12. What is the ratio of the Mortality Rate(per 1000 female or male adults) in Greece in 1969 to that in 1975?
Offer a very short reply. 1.09. What is the ratio of the Mortality Rate(per 1000 female or male adults) in Lao PDR in 1969 to that in 1975?
Ensure brevity in your answer.  1.05. What is the ratio of the Mortality Rate(per 1000 female or male adults) of Cyprus in 1970 to that in 1971?
Your answer should be very brief. 1.02. What is the ratio of the Mortality Rate(per 1000 female or male adults) in Greece in 1970 to that in 1971?
Provide a succinct answer. 1.01. What is the ratio of the Mortality Rate(per 1000 female or male adults) of Lao PDR in 1970 to that in 1971?
Your answer should be compact. 1.01. What is the ratio of the Mortality Rate(per 1000 female or male adults) of Cyprus in 1970 to that in 1972?
Your answer should be compact. 1.04. What is the ratio of the Mortality Rate(per 1000 female or male adults) of Greece in 1970 to that in 1972?
Ensure brevity in your answer.  1.03. What is the ratio of the Mortality Rate(per 1000 female or male adults) of Cyprus in 1970 to that in 1973?
Ensure brevity in your answer.  1.06. What is the ratio of the Mortality Rate(per 1000 female or male adults) of Greece in 1970 to that in 1973?
Provide a short and direct response. 1.05. What is the ratio of the Mortality Rate(per 1000 female or male adults) in Lao PDR in 1970 to that in 1973?
Ensure brevity in your answer.  1.02. What is the ratio of the Mortality Rate(per 1000 female or male adults) of Cyprus in 1970 to that in 1974?
Provide a short and direct response. 1.08. What is the ratio of the Mortality Rate(per 1000 female or male adults) in Greece in 1970 to that in 1974?
Ensure brevity in your answer.  1.06. What is the ratio of the Mortality Rate(per 1000 female or male adults) in Lao PDR in 1970 to that in 1974?
Ensure brevity in your answer.  1.03. What is the ratio of the Mortality Rate(per 1000 female or male adults) of Cyprus in 1970 to that in 1975?
Ensure brevity in your answer.  1.1. What is the ratio of the Mortality Rate(per 1000 female or male adults) of Greece in 1970 to that in 1975?
Make the answer very short. 1.08. What is the ratio of the Mortality Rate(per 1000 female or male adults) of Lao PDR in 1970 to that in 1975?
Your answer should be very brief. 1.04. What is the ratio of the Mortality Rate(per 1000 female or male adults) of Cyprus in 1971 to that in 1972?
Your response must be concise. 1.02. What is the ratio of the Mortality Rate(per 1000 female or male adults) of Greece in 1971 to that in 1972?
Offer a very short reply. 1.01. What is the ratio of the Mortality Rate(per 1000 female or male adults) in Lao PDR in 1971 to that in 1972?
Your answer should be very brief. 1.01. What is the ratio of the Mortality Rate(per 1000 female or male adults) of Cyprus in 1971 to that in 1973?
Ensure brevity in your answer.  1.04. What is the ratio of the Mortality Rate(per 1000 female or male adults) of Greece in 1971 to that in 1973?
Your response must be concise. 1.03. What is the ratio of the Mortality Rate(per 1000 female or male adults) in Lao PDR in 1971 to that in 1973?
Your answer should be compact. 1.02. What is the ratio of the Mortality Rate(per 1000 female or male adults) in Cyprus in 1971 to that in 1974?
Offer a terse response. 1.06. What is the ratio of the Mortality Rate(per 1000 female or male adults) in Greece in 1971 to that in 1974?
Ensure brevity in your answer.  1.05. What is the ratio of the Mortality Rate(per 1000 female or male adults) in Lao PDR in 1971 to that in 1974?
Offer a very short reply. 1.02. What is the ratio of the Mortality Rate(per 1000 female or male adults) in Cyprus in 1971 to that in 1975?
Your answer should be compact. 1.08. What is the ratio of the Mortality Rate(per 1000 female or male adults) of Greece in 1971 to that in 1975?
Your response must be concise. 1.06. What is the ratio of the Mortality Rate(per 1000 female or male adults) in Lao PDR in 1971 to that in 1975?
Offer a very short reply. 1.03. What is the ratio of the Mortality Rate(per 1000 female or male adults) in Cyprus in 1972 to that in 1973?
Your answer should be very brief. 1.02. What is the ratio of the Mortality Rate(per 1000 female or male adults) of Greece in 1972 to that in 1973?
Make the answer very short. 1.02. What is the ratio of the Mortality Rate(per 1000 female or male adults) of Lao PDR in 1972 to that in 1973?
Your answer should be very brief. 1.01. What is the ratio of the Mortality Rate(per 1000 female or male adults) in Cyprus in 1972 to that in 1974?
Keep it short and to the point. 1.04. What is the ratio of the Mortality Rate(per 1000 female or male adults) in Greece in 1972 to that in 1974?
Offer a very short reply. 1.03. What is the ratio of the Mortality Rate(per 1000 female or male adults) of Lao PDR in 1972 to that in 1974?
Give a very brief answer. 1.01. What is the ratio of the Mortality Rate(per 1000 female or male adults) in Cyprus in 1972 to that in 1975?
Make the answer very short. 1.06. What is the ratio of the Mortality Rate(per 1000 female or male adults) in Greece in 1972 to that in 1975?
Your answer should be very brief. 1.05. What is the ratio of the Mortality Rate(per 1000 female or male adults) in Lao PDR in 1972 to that in 1975?
Provide a succinct answer. 1.02. What is the ratio of the Mortality Rate(per 1000 female or male adults) in Cyprus in 1973 to that in 1974?
Give a very brief answer. 1.02. What is the ratio of the Mortality Rate(per 1000 female or male adults) in Greece in 1973 to that in 1974?
Offer a terse response. 1.02. What is the ratio of the Mortality Rate(per 1000 female or male adults) of Lao PDR in 1973 to that in 1974?
Offer a terse response. 1.01. What is the ratio of the Mortality Rate(per 1000 female or male adults) in Cyprus in 1973 to that in 1975?
Ensure brevity in your answer.  1.04. What is the ratio of the Mortality Rate(per 1000 female or male adults) of Greece in 1973 to that in 1975?
Offer a very short reply. 1.03. What is the ratio of the Mortality Rate(per 1000 female or male adults) of Lao PDR in 1973 to that in 1975?
Your answer should be compact. 1.01. What is the ratio of the Mortality Rate(per 1000 female or male adults) of Cyprus in 1974 to that in 1975?
Offer a terse response. 1.02. What is the ratio of the Mortality Rate(per 1000 female or male adults) in Greece in 1974 to that in 1975?
Make the answer very short. 1.02. What is the ratio of the Mortality Rate(per 1000 female or male adults) of Lao PDR in 1974 to that in 1975?
Your response must be concise. 1.01. What is the difference between the highest and the second highest Mortality Rate(per 1000 female or male adults) of Cyprus?
Make the answer very short. 1.52. What is the difference between the highest and the second highest Mortality Rate(per 1000 female or male adults) of Greece?
Provide a succinct answer. 1.52. What is the difference between the highest and the second highest Mortality Rate(per 1000 female or male adults) of Lao PDR?
Provide a succinct answer. 3.18. What is the difference between the highest and the lowest Mortality Rate(per 1000 female or male adults) of Cyprus?
Provide a short and direct response. 10.23. What is the difference between the highest and the lowest Mortality Rate(per 1000 female or male adults) of Greece?
Give a very brief answer. 10.67. What is the difference between the highest and the lowest Mortality Rate(per 1000 female or male adults) in Lao PDR?
Your answer should be compact. 20.58. 